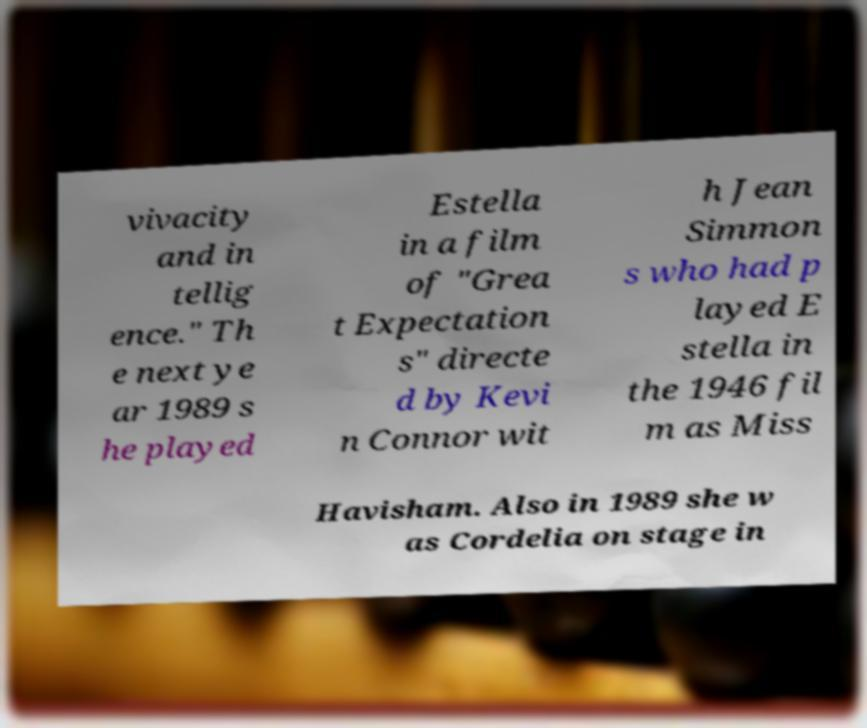Can you accurately transcribe the text from the provided image for me? vivacity and in tellig ence." Th e next ye ar 1989 s he played Estella in a film of "Grea t Expectation s" directe d by Kevi n Connor wit h Jean Simmon s who had p layed E stella in the 1946 fil m as Miss Havisham. Also in 1989 she w as Cordelia on stage in 